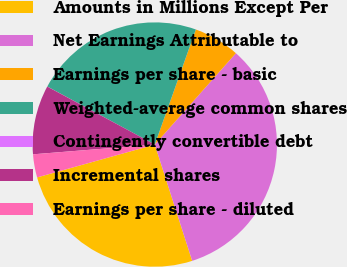<chart> <loc_0><loc_0><loc_500><loc_500><pie_chart><fcel>Amounts in Millions Except Per<fcel>Net Earnings Attributable to<fcel>Earnings per share - basic<fcel>Weighted-average common shares<fcel>Contingently convertible debt<fcel>Incremental shares<fcel>Earnings per share - diluted<nl><fcel>25.62%<fcel>33.49%<fcel>6.1%<fcel>22.58%<fcel>0.01%<fcel>9.14%<fcel>3.06%<nl></chart> 